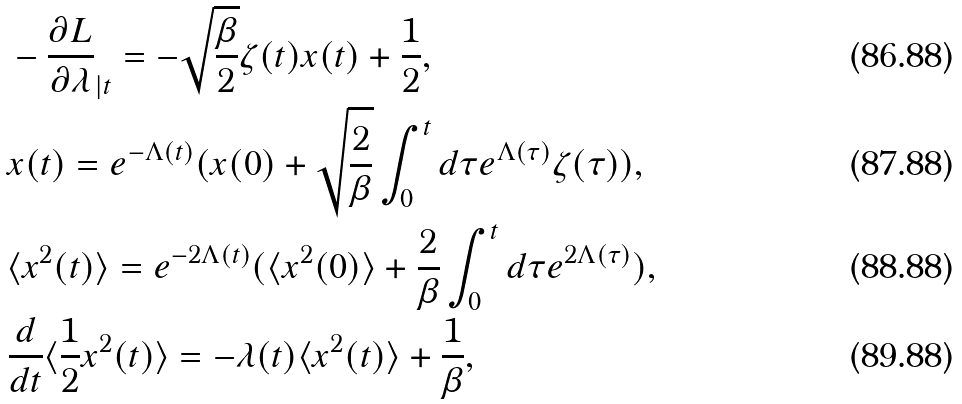<formula> <loc_0><loc_0><loc_500><loc_500>& - \frac { \partial L } { \partial \lambda } _ { | t } = - \sqrt { \frac { \beta } { 2 } } \zeta ( t ) x ( t ) + \frac { 1 } { 2 } , \\ & x ( t ) = e ^ { - \Lambda ( t ) } ( x ( 0 ) + \sqrt { \frac { 2 } { \beta } } \int _ { 0 } ^ { t } d \tau e ^ { \Lambda ( \tau ) } \zeta ( \tau ) ) , \\ & \langle x ^ { 2 } ( t ) \rangle = e ^ { - 2 \Lambda ( t ) } ( \langle x ^ { 2 } ( 0 ) \rangle + \frac { 2 } { \beta } \int _ { 0 } ^ { t } d \tau e ^ { 2 \Lambda ( \tau ) } ) , \\ & \frac { d } { d t } \langle \frac { 1 } { 2 } x ^ { 2 } ( t ) \rangle = - \lambda ( t ) \langle x ^ { 2 } ( t ) \rangle + \frac { 1 } { \beta } ,</formula> 